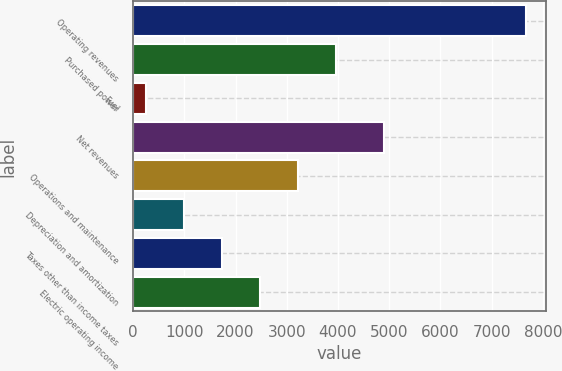Convert chart. <chart><loc_0><loc_0><loc_500><loc_500><bar_chart><fcel>Operating revenues<fcel>Purchased power<fcel>Fuel<fcel>Net revenues<fcel>Operations and maintenance<fcel>Depreciation and amortization<fcel>Taxes other than income taxes<fcel>Electric operating income<nl><fcel>7674<fcel>3960.5<fcel>247<fcel>4898<fcel>3217.8<fcel>989.7<fcel>1732.4<fcel>2475.1<nl></chart> 